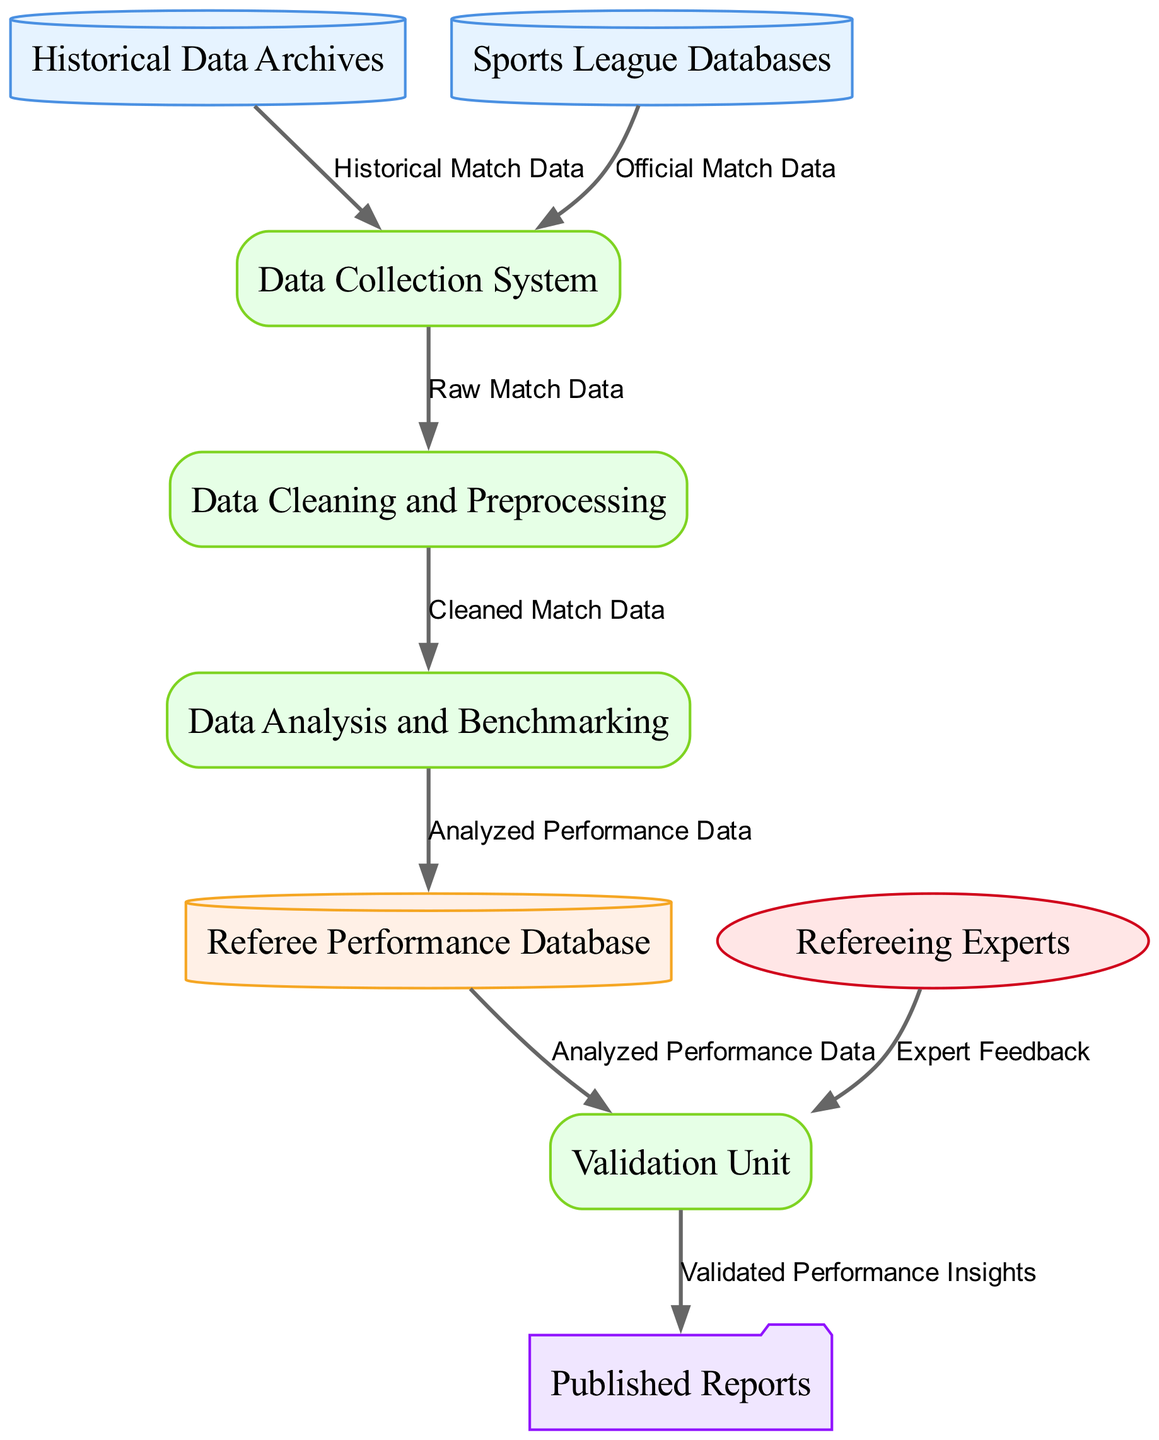What are the two main data sources in this workflow? The two main data sources are "Historical Data Archives" and "Sports League Databases". Both are mentioned as sources that provide historical match data to the system for collection.
Answer: Historical Data Archives, Sports League Databases How many processes are involved in the historical data collection and analysis workflow? The diagram lists four processes: Data Collection System, Data Cleaning and Preprocessing, Data Analysis and Benchmarking, and Validation Unit. By counting each of these processes depicted in the diagram, we find there are four.
Answer: Four Which entity is responsible for validating the analysis results? The "Validation Unit" is mentioned in the diagram as the entity that is responsible for validating the analysis results to ensure their accuracy and reliability.
Answer: Validation Unit What kind of data does the "Data Cleaning and Preprocessing" process receive? The "Data Cleaning and Preprocessing" process receives "Raw Match Data," which comes directly from the "Data Collection System". This relationship is illustrated in the flow between these two entities.
Answer: Raw Match Data What is the output of the "Validation Unit"? The output of the "Validation Unit" is "Validated Performance Insights". This is the information that gets delivered to the "Published Reports" according to the flow shown in the diagram.
Answer: Validated Performance Insights How does the feedback from "Refereeing Experts" contribute to the workflow? The "Expert Feedback" from "Refereeing Experts" is sent to the "Validation Unit", providing essential insights that aid in confirming the analysis results, ensuring that the validation process is thorough and reflects expert input.
Answer: Validation Unit How many edges are there in the data flow diagram? By counting the directed edges connecting the nodes in the diagram, we find there are eight data flows depicted, which represent the transitions of data between the various entities and processes.
Answer: Eight Which process leads to the "Referee Performance Database"? The "Data Analysis and Benchmarking" process leads to the "Referee Performance Database". The diagram shows this connection, indicating that the analyzed performance data flows into this repository.
Answer: Data Analysis and Benchmarking 